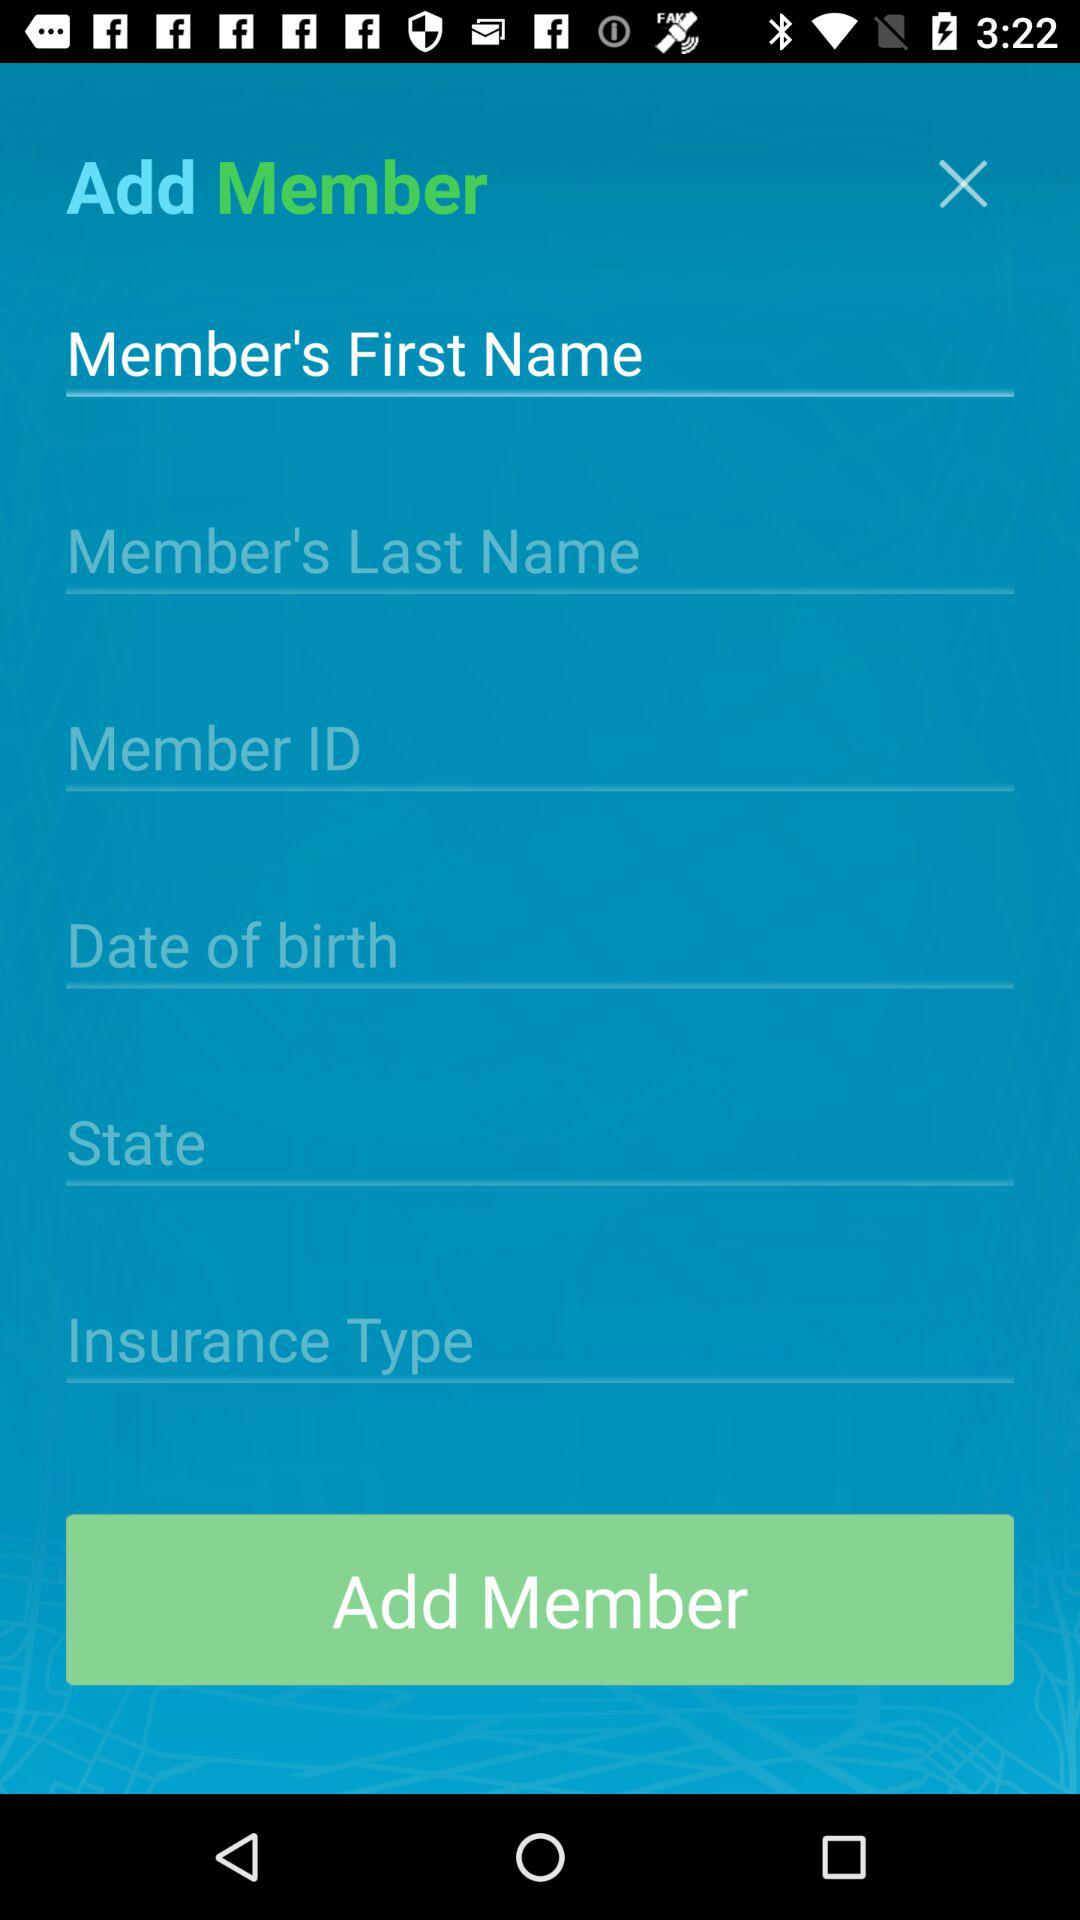How many input fields are there for the member's personal information?
Answer the question using a single word or phrase. 6 